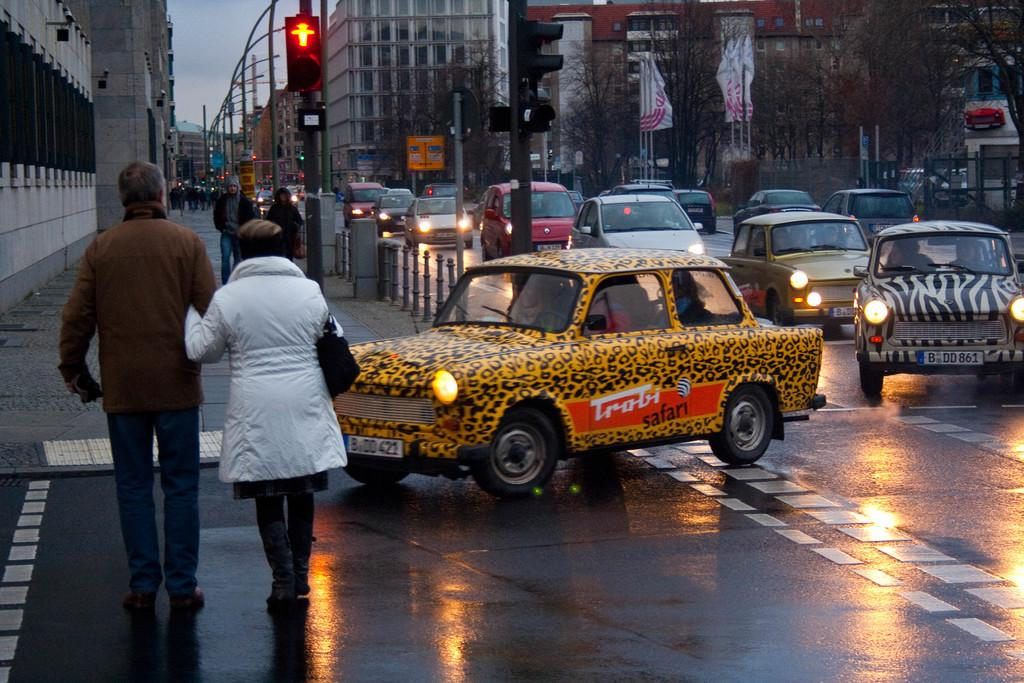<image>
Render a clear and concise summary of the photo. A cheetah print car with the words Trobi Safari written on the door drives down a rainy street. 